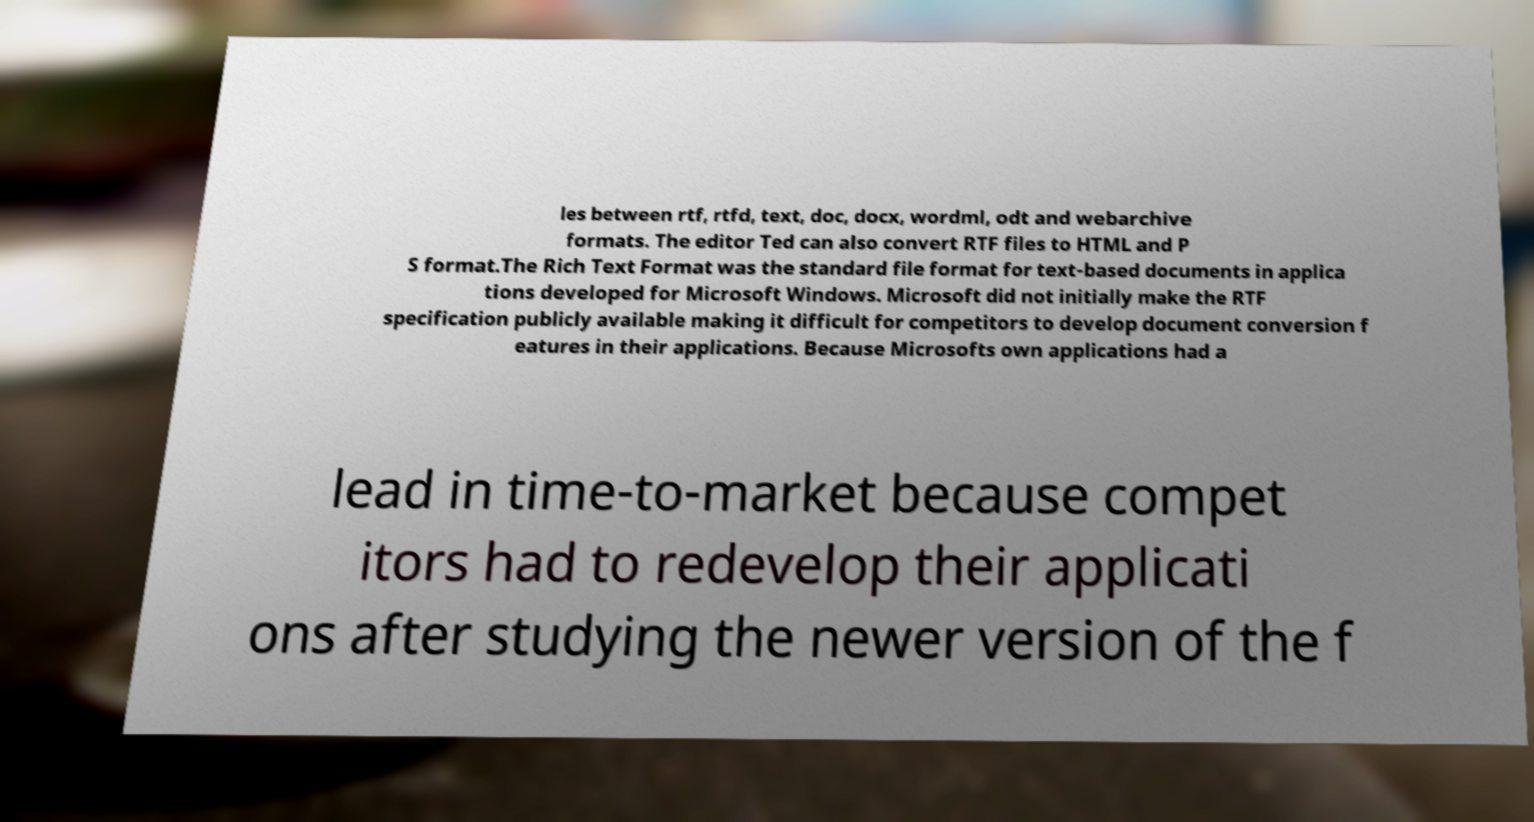There's text embedded in this image that I need extracted. Can you transcribe it verbatim? les between rtf, rtfd, text, doc, docx, wordml, odt and webarchive formats. The editor Ted can also convert RTF files to HTML and P S format.The Rich Text Format was the standard file format for text-based documents in applica tions developed for Microsoft Windows. Microsoft did not initially make the RTF specification publicly available making it difficult for competitors to develop document conversion f eatures in their applications. Because Microsofts own applications had a lead in time-to-market because compet itors had to redevelop their applicati ons after studying the newer version of the f 